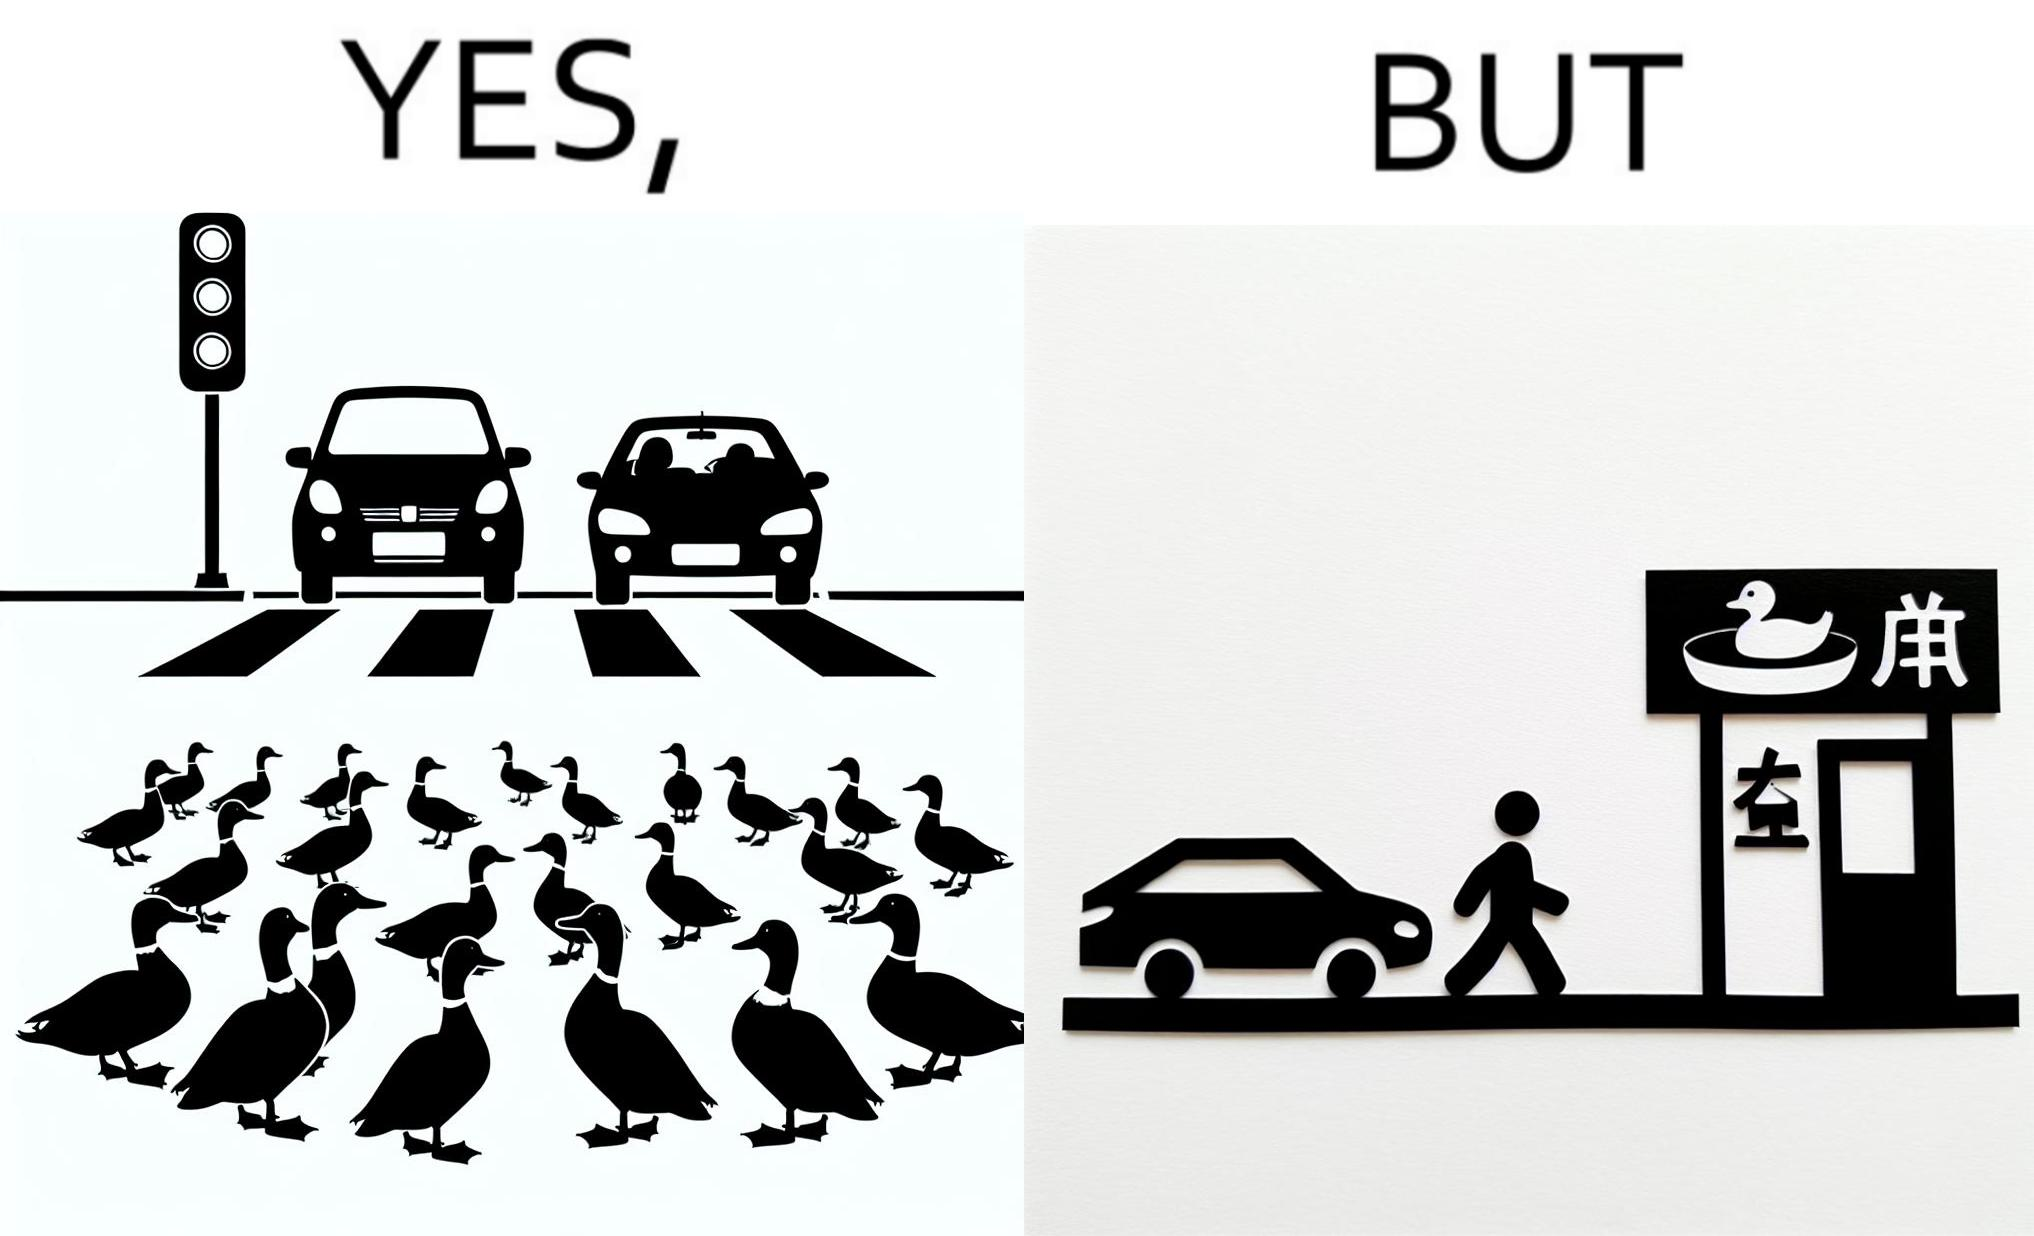Describe the content of this image. The images are ironic since they show how a man supposedly cares for ducks since he stops his vehicle to give way to queue of ducks allowing them to safely cross a road but on the other hand he goes to a peking duck shop to buy and eat similar ducks after having them killed 